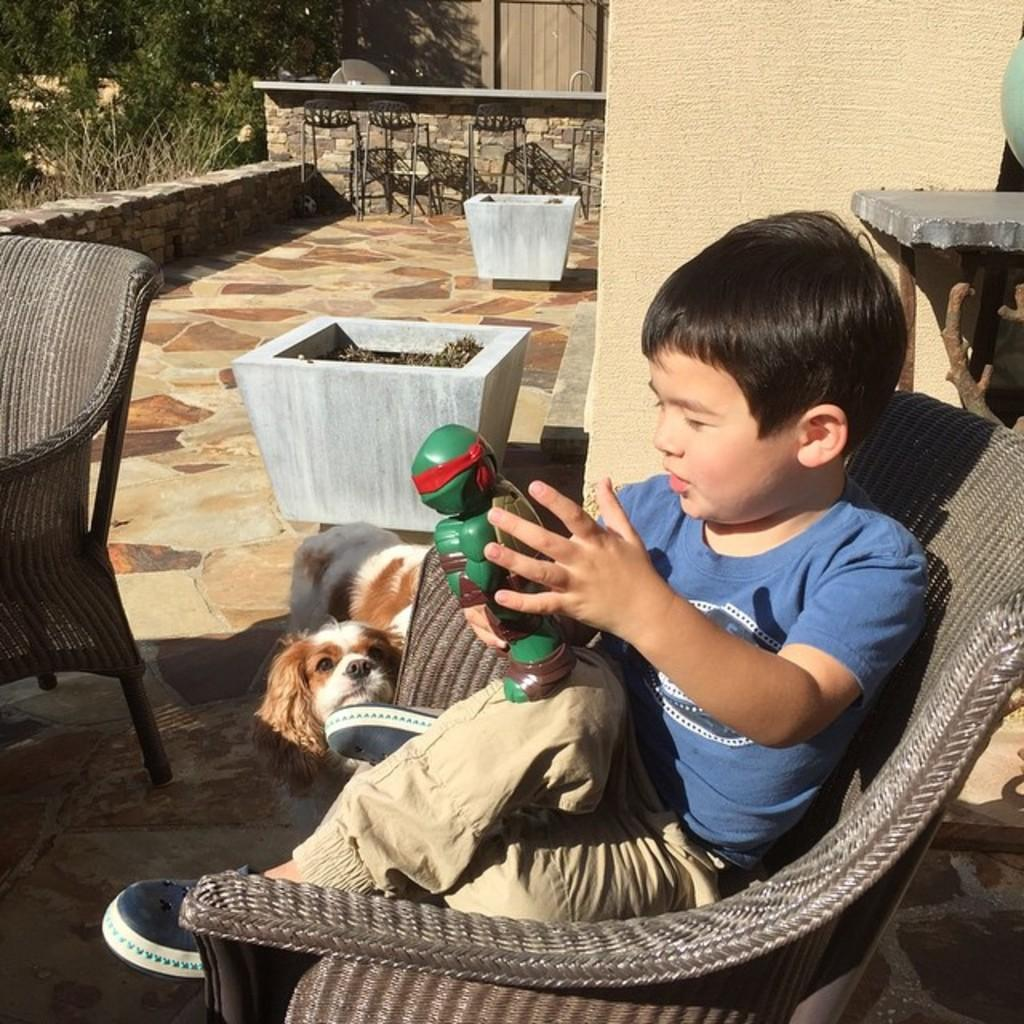Who is the main subject in the image? There is a boy in the image. What is the boy doing in the image? The boy is sitting on a chair. Is there any other living creature in the image? Yes, there is a dog in the image. Where is the dog located in the image? The dog is on the floor. What is the boy holding in his hand? The boy is holding a toy in his hand. Can you see any alley or lake in the image? No, there is no alley or lake present in the image. Is the boy's parent visible in the image? No, the boy's parent is not visible in the image. 